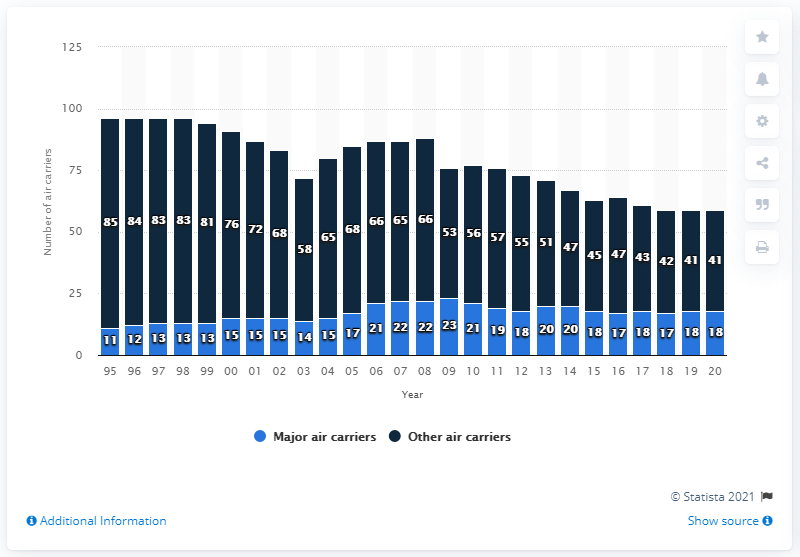Specify some key components in this picture. In 2020, there were 18 commercial air carriers operating in the United States. In 2008, there were 22 major carriers. There were 41 smaller air carriers in 2008. 